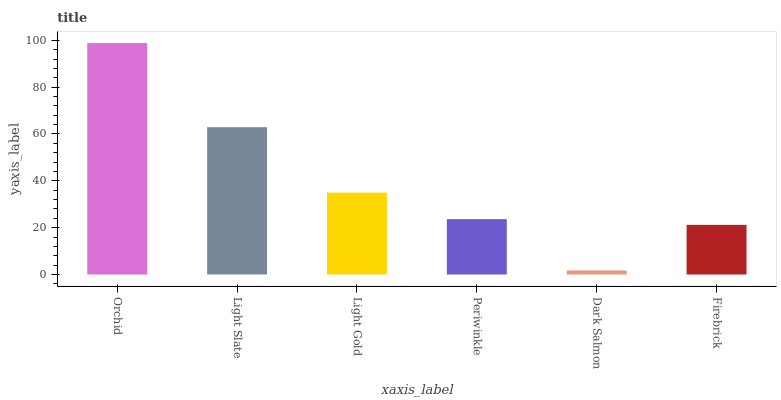Is Light Slate the minimum?
Answer yes or no. No. Is Light Slate the maximum?
Answer yes or no. No. Is Orchid greater than Light Slate?
Answer yes or no. Yes. Is Light Slate less than Orchid?
Answer yes or no. Yes. Is Light Slate greater than Orchid?
Answer yes or no. No. Is Orchid less than Light Slate?
Answer yes or no. No. Is Light Gold the high median?
Answer yes or no. Yes. Is Periwinkle the low median?
Answer yes or no. Yes. Is Light Slate the high median?
Answer yes or no. No. Is Firebrick the low median?
Answer yes or no. No. 